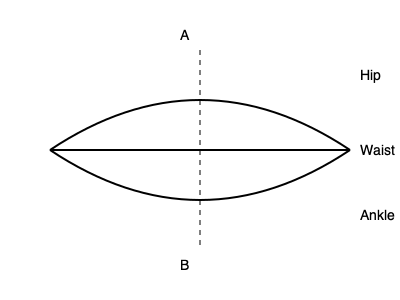In the cross-sectional diagram of bell-bottom pants, what is the significance of the ratio between measurements A and B in determining the flare of the pants? To understand the flare of bell-bottom pants, we need to analyze the cross-sectional diagram:

1. The diagram shows a cross-section of bell-bottom pants from the waist to the ankle.
2. The vertical dashed line represents the center of the pants.
3. Measurement A is the width at the hip level.
4. Measurement B is the width at the ankle level.
5. The flare of bell-bottom pants is characterized by a wider opening at the bottom compared to the hip area.
6. To quantify the flare, we can use the ratio B:A.
7. A higher B:A ratio indicates a more pronounced flare.
8. For classic 70s style bell-bottoms, the B:A ratio typically ranges from 1.5:1 to 2:1.
9. This ratio ensures that the pants widen significantly from the hip to the ankle, creating the iconic bell shape.
10. A lower ratio (closer to 1:1) would result in a straight-leg or slightly flared design.
11. A higher ratio (above 2:1) would create an exaggerated flare, which might be suitable for costume designs.

The B:A ratio is crucial in determining the degree of flare in bell-bottom pants, allowing manufacturers to create authentic 60s, 70s, and 80s styles with varying levels of dramatic silhouettes.
Answer: The B:A ratio determines the degree of flare in bell-bottom pants. 